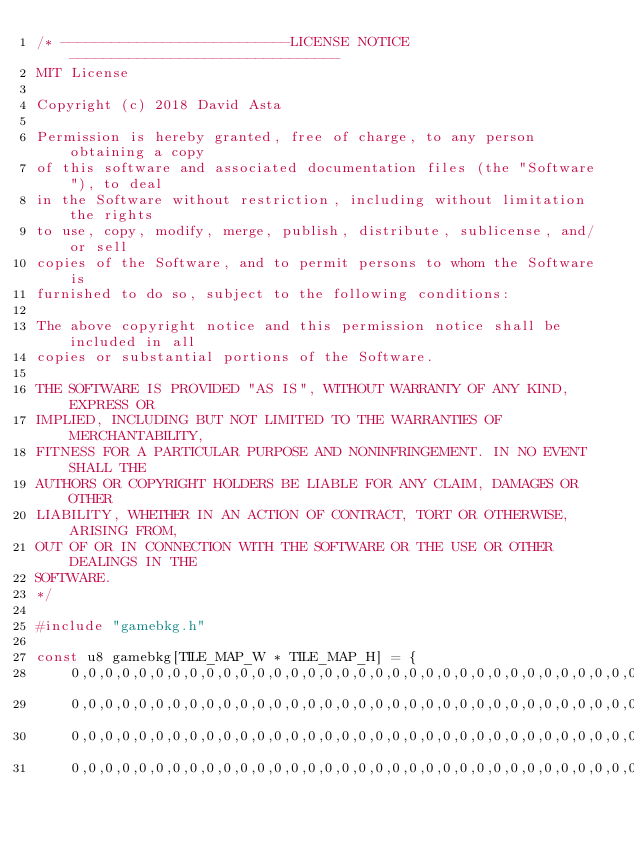Convert code to text. <code><loc_0><loc_0><loc_500><loc_500><_C_>/* ---------------------------LICENSE NOTICE-------------------------------- 
MIT License

Copyright (c) 2018 David Asta

Permission is hereby granted, free of charge, to any person obtaining a copy
of this software and associated documentation files (the "Software"), to deal
in the Software without restriction, including without limitation the rights
to use, copy, modify, merge, publish, distribute, sublicense, and/or sell
copies of the Software, and to permit persons to whom the Software is
furnished to do so, subject to the following conditions:

The above copyright notice and this permission notice shall be included in all
copies or substantial portions of the Software.

THE SOFTWARE IS PROVIDED "AS IS", WITHOUT WARRANTY OF ANY KIND, EXPRESS OR
IMPLIED, INCLUDING BUT NOT LIMITED TO THE WARRANTIES OF MERCHANTABILITY,
FITNESS FOR A PARTICULAR PURPOSE AND NONINFRINGEMENT. IN NO EVENT SHALL THE
AUTHORS OR COPYRIGHT HOLDERS BE LIABLE FOR ANY CLAIM, DAMAGES OR OTHER
LIABILITY, WHETHER IN AN ACTION OF CONTRACT, TORT OR OTHERWISE, ARISING FROM,
OUT OF OR IN CONNECTION WITH THE SOFTWARE OR THE USE OR OTHER DEALINGS IN THE
SOFTWARE.
*/

#include "gamebkg.h"

const u8 gamebkg[TILE_MAP_W * TILE_MAP_H] = {
    0,0,0,0,0,0,0,0,0,0,0,0,0,0,0,0,0,0,0,0,0,0,0,0,0,0,0,0,0,0,0,0,0,0,0,0,0,0,0,0,
    0,0,0,0,0,0,0,0,0,0,0,0,0,0,0,0,0,0,0,0,0,0,0,0,0,0,0,0,0,0,0,0,0,0,0,0,0,0,0,0,
    0,0,0,0,0,0,0,0,0,0,0,0,0,0,0,0,0,0,0,0,0,0,0,0,0,0,0,0,0,0,0,0,0,0,0,0,0,0,0,0,
    0,0,0,0,0,0,0,0,0,0,0,0,0,0,0,0,0,0,0,0,0,0,0,0,0,0,0,0,0,0,0,0,0,0,0,0,0,0,0,0,</code> 